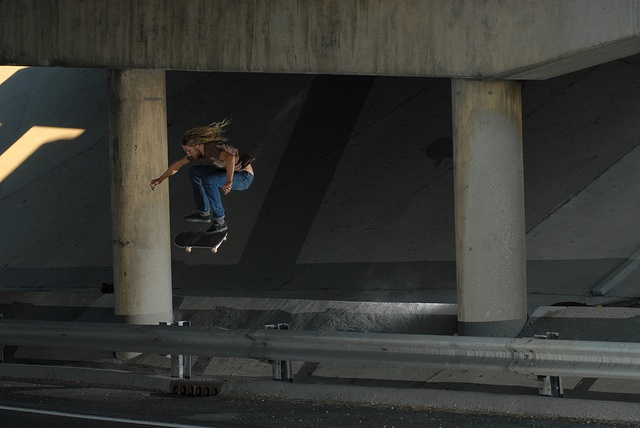Describe the objects in this image and their specific colors. I can see people in black, maroon, gray, and blue tones and skateboard in black, gray, and darkgray tones in this image. 